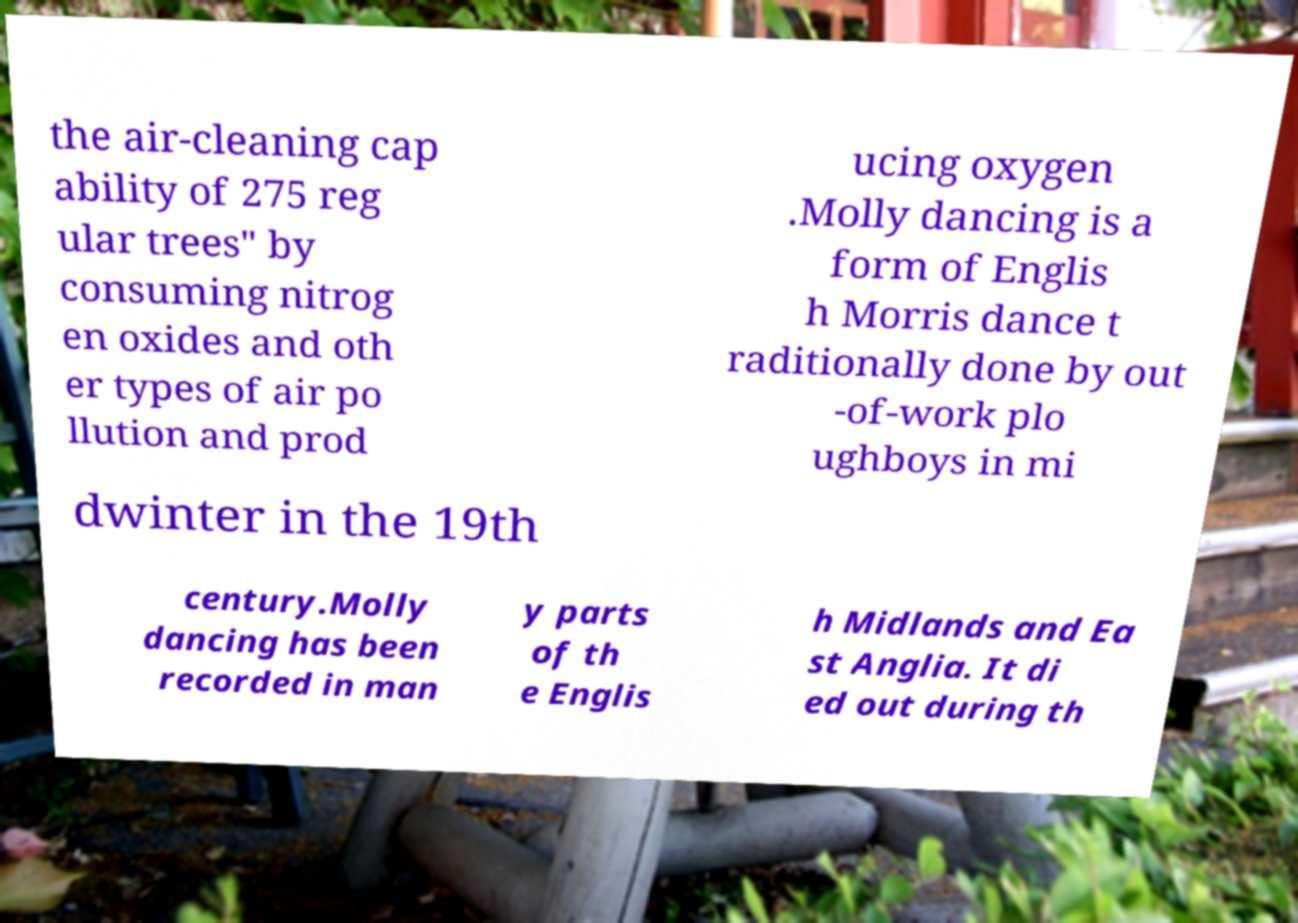Please identify and transcribe the text found in this image. the air-cleaning cap ability of 275 reg ular trees" by consuming nitrog en oxides and oth er types of air po llution and prod ucing oxygen .Molly dancing is a form of Englis h Morris dance t raditionally done by out -of-work plo ughboys in mi dwinter in the 19th century.Molly dancing has been recorded in man y parts of th e Englis h Midlands and Ea st Anglia. It di ed out during th 